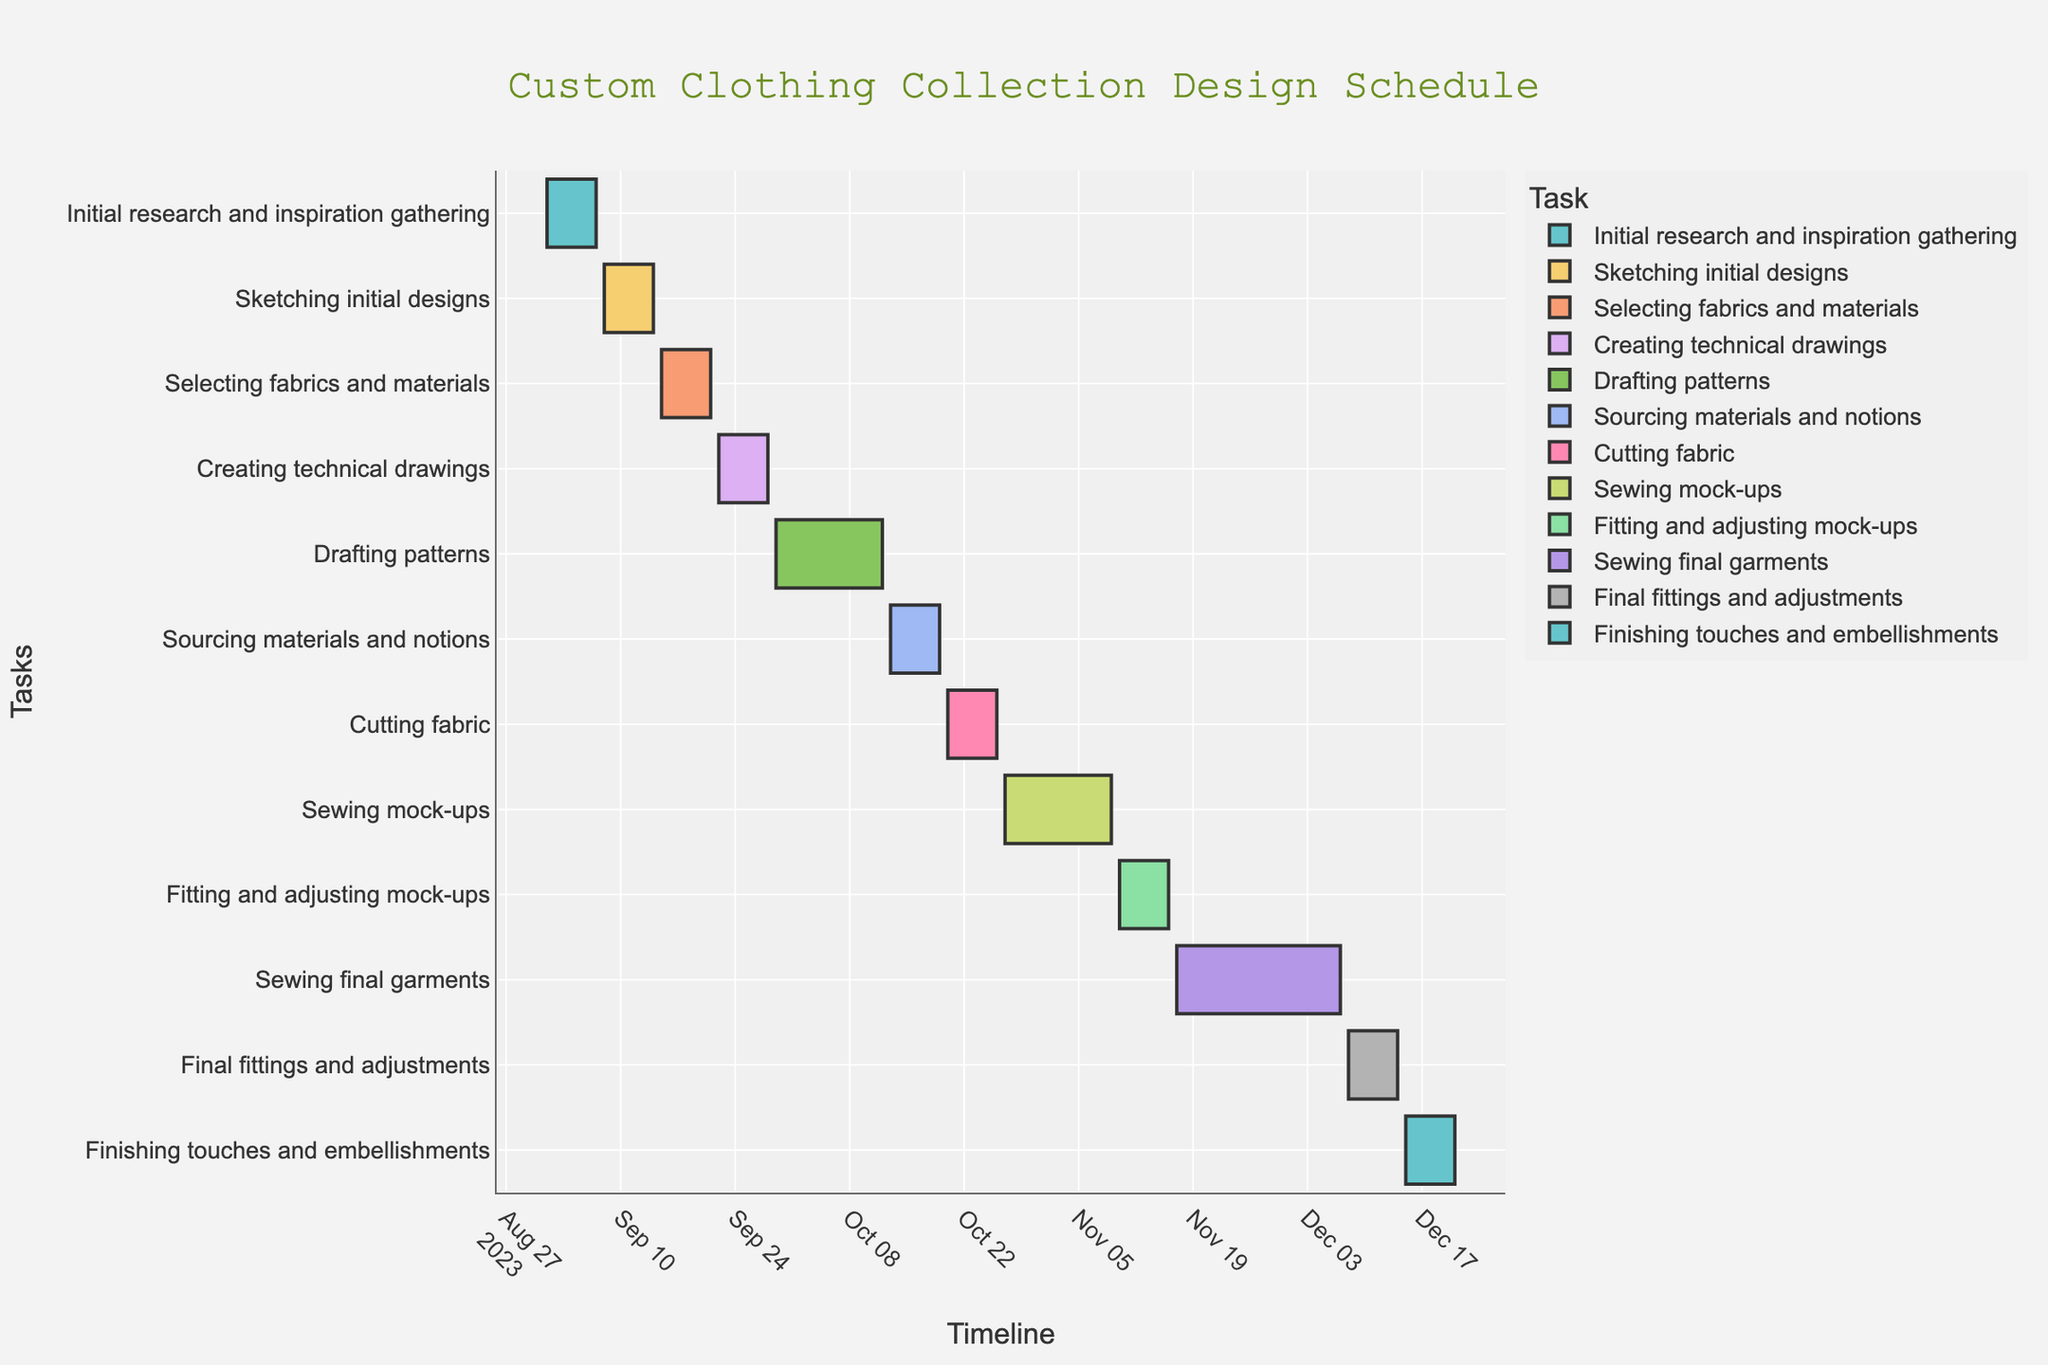What's the title of the Gantt chart? The title is displayed at the top center of the Gantt chart and typically provides an overview of what the chart represents. By looking at the top center of the plot, you'll find the text title.
Answer: Custom Clothing Collection Design Schedule When does the 'Cutting fabric' task start? Each task has its start date marked on the horizontal timeline. By locating the 'Cutting fabric' task on the y-axis and checking its corresponding starting point on the x-axis, we can find the start date.
Answer: October 20, 2023 Which task ends last on the schedule? By examining the rightmost end of the Gantt chart, we can identify which task has the furthest end date. Look for the task that stretches furthest to the right on the timeline.
Answer: Finishing touches and embellishments How many days are allocated for 'Sewing mock-ups'? To calculate the total days for 'Sewing mock-ups', identify its start date (October 27, 2023) and end date (November 9, 2023), then find the difference between these dates.
Answer: 14 days Which task takes longer, 'Drafting patterns' or 'Sewing final garments'? First, determine the duration for each task by subtracting the start date from the end date. 'Drafting patterns' runs from September 29 to October 12 (14 days). 'Sewing final garments' runs from November 17 to December 7 (21 days). Compare the two durations.
Answer: Sewing final garments Which tasks are scheduled to run two weeks or more? To identify tasks with durations of 14 days or more, find the duration of each task by subtracting the start date from the end date. List those whose durations are 14 days or more.
Answer: Drafting patterns, Sewing mock-ups, Sewing final garments What is the total duration of the entire schedule from start to finish? Determine the start date of the first task and the end date of the last task to measure the total schedule duration. Start: September 1, 2023; End: December 21, 2023. Subtract the start date from the end date.
Answer: 112 days Are there any tasks that overlap? Tasks that overlap will have bars that share the same horizontal space on the timeline. By examining the Gantt chart visually, identify tasks with overlapping timelines.
Answer: Yes (e.g., Drafting patterns and Creating technical drawings) Which task starts immediately after 'Selecting fabrics and materials'? Locate the end date of 'Selecting fabrics and materials' (September 21) and find the task that begins on the next calendar day.
Answer: Creating technical drawings When does the 'Final fittings and adjustments' task end? Identify 'Final fittings and adjustments' on the y-axis and follow it to the rightmost end to find its concluding date.
Answer: December 14, 2023 